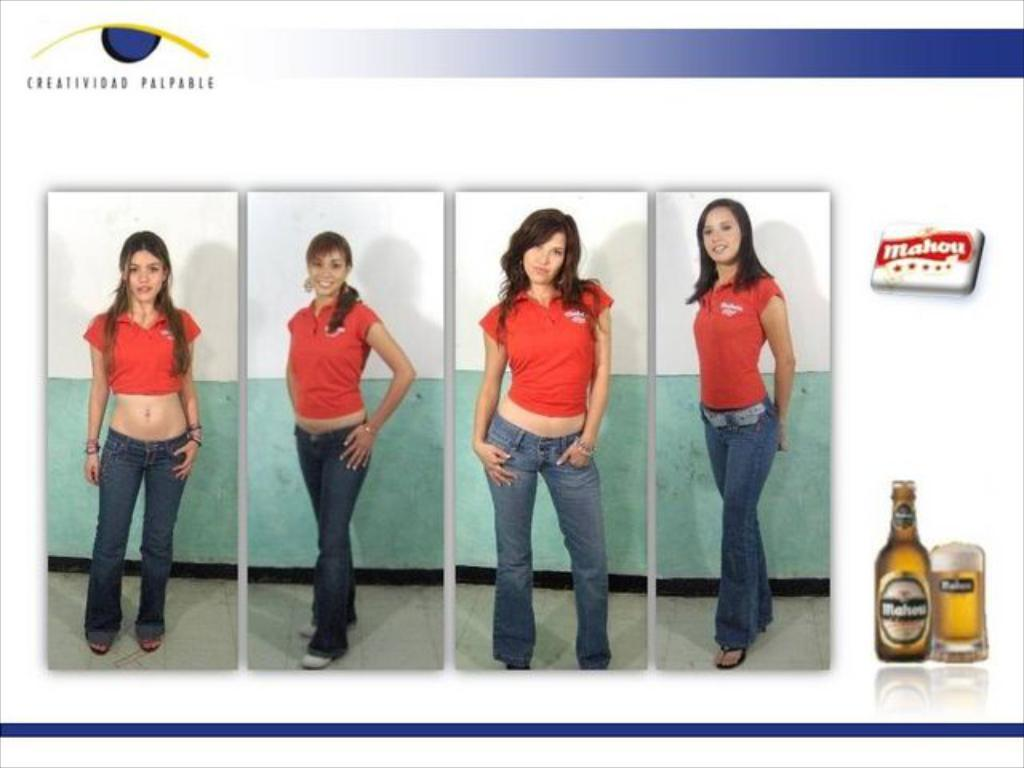What can be seen in the image regarding people? There are women standing in the image. Where are the women positioned in the image? The women are standing on the floor. What is the image of a bottle associated with? There is a picture of a bottle in the image. What is in the glass that is visible in the image? There is a glass with beer in the image. What additional design elements are present in the image? There is a logo and some text in the image. Can you see any wings on the women in the image? No, there are no wings visible on the women in the image. Is there a trail leading to the women in the image? No, there is no trail present in the image. 